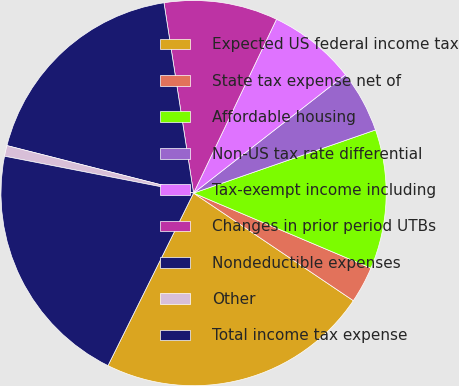Convert chart. <chart><loc_0><loc_0><loc_500><loc_500><pie_chart><fcel>Expected US federal income tax<fcel>State tax expense net of<fcel>Affordable housing<fcel>Non-US tax rate differential<fcel>Tax-exempt income including<fcel>Changes in prior period UTBs<fcel>Nondeductible expenses<fcel>Other<fcel>Total income tax expense<nl><fcel>22.9%<fcel>3.06%<fcel>11.69%<fcel>5.22%<fcel>7.38%<fcel>9.54%<fcel>18.58%<fcel>0.9%<fcel>20.74%<nl></chart> 